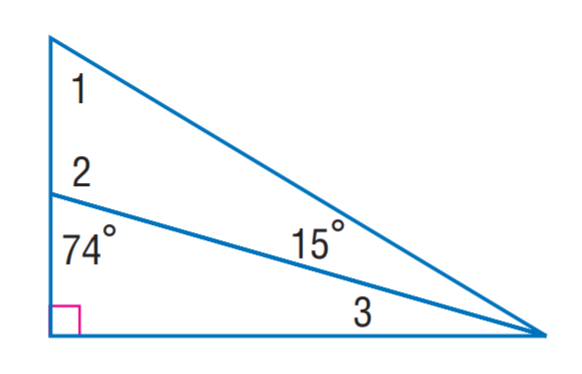Answer the mathemtical geometry problem and directly provide the correct option letter.
Question: Find m \angle 1.
Choices: A: 15 B: 43 C: 59 D: 71 C 